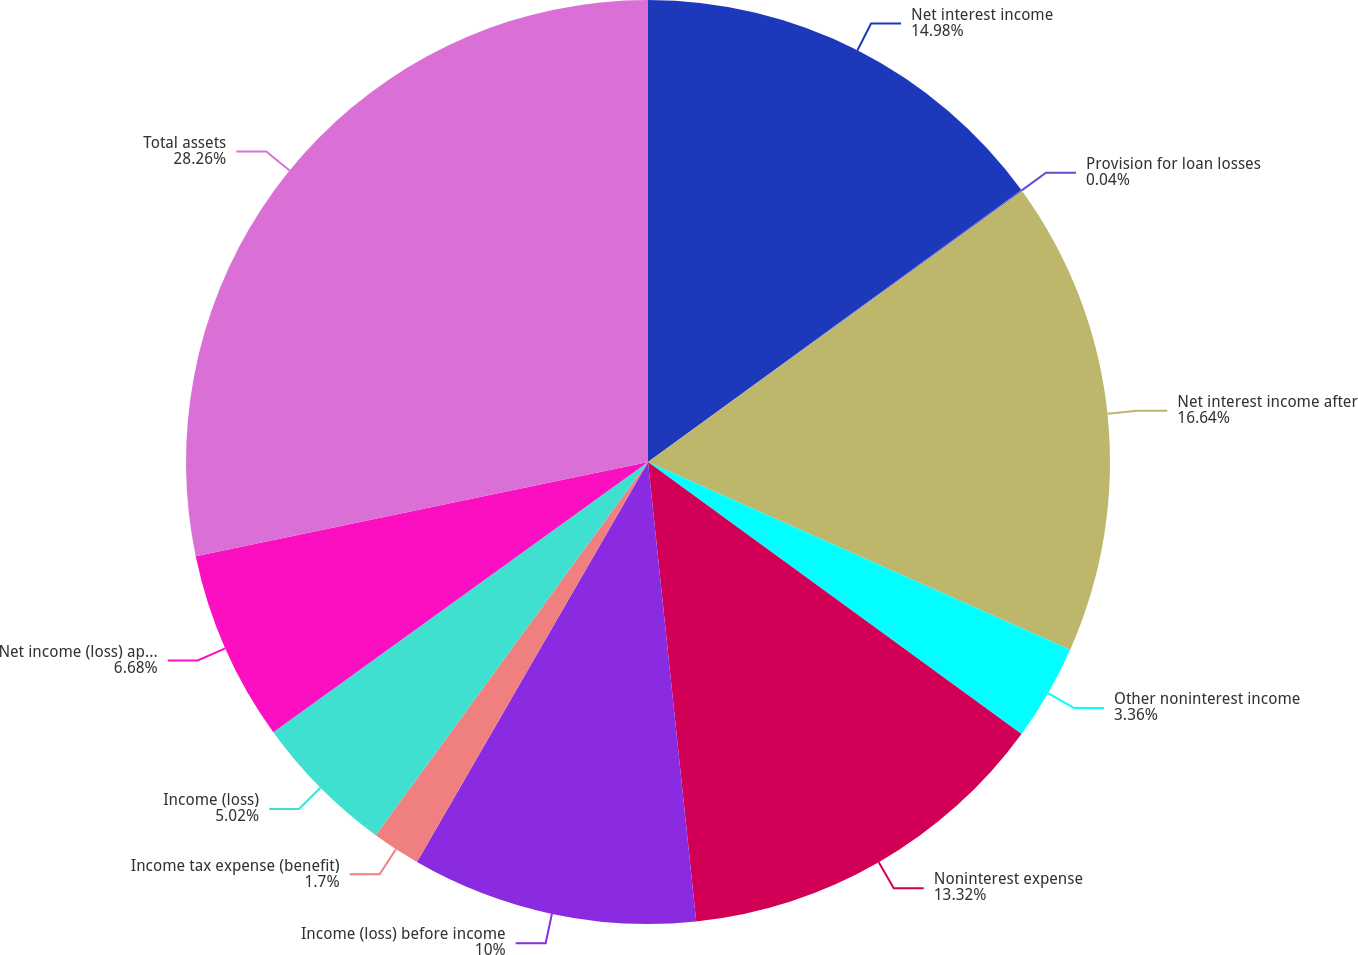Convert chart. <chart><loc_0><loc_0><loc_500><loc_500><pie_chart><fcel>Net interest income<fcel>Provision for loan losses<fcel>Net interest income after<fcel>Other noninterest income<fcel>Noninterest expense<fcel>Income (loss) before income<fcel>Income tax expense (benefit)<fcel>Income (loss)<fcel>Net income (loss) applicable<fcel>Total assets<nl><fcel>14.98%<fcel>0.04%<fcel>16.64%<fcel>3.36%<fcel>13.32%<fcel>10.0%<fcel>1.7%<fcel>5.02%<fcel>6.68%<fcel>28.27%<nl></chart> 